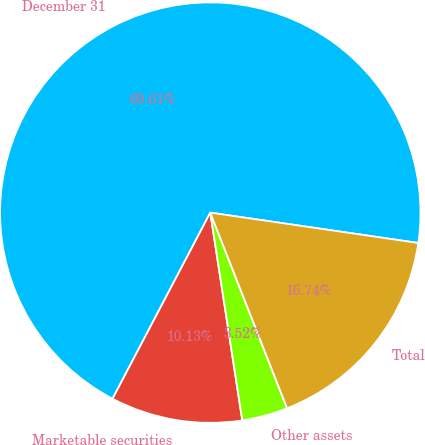Convert chart to OTSL. <chart><loc_0><loc_0><loc_500><loc_500><pie_chart><fcel>December 31<fcel>Marketable securities<fcel>Other assets<fcel>Total<nl><fcel>69.61%<fcel>10.13%<fcel>3.52%<fcel>16.74%<nl></chart> 